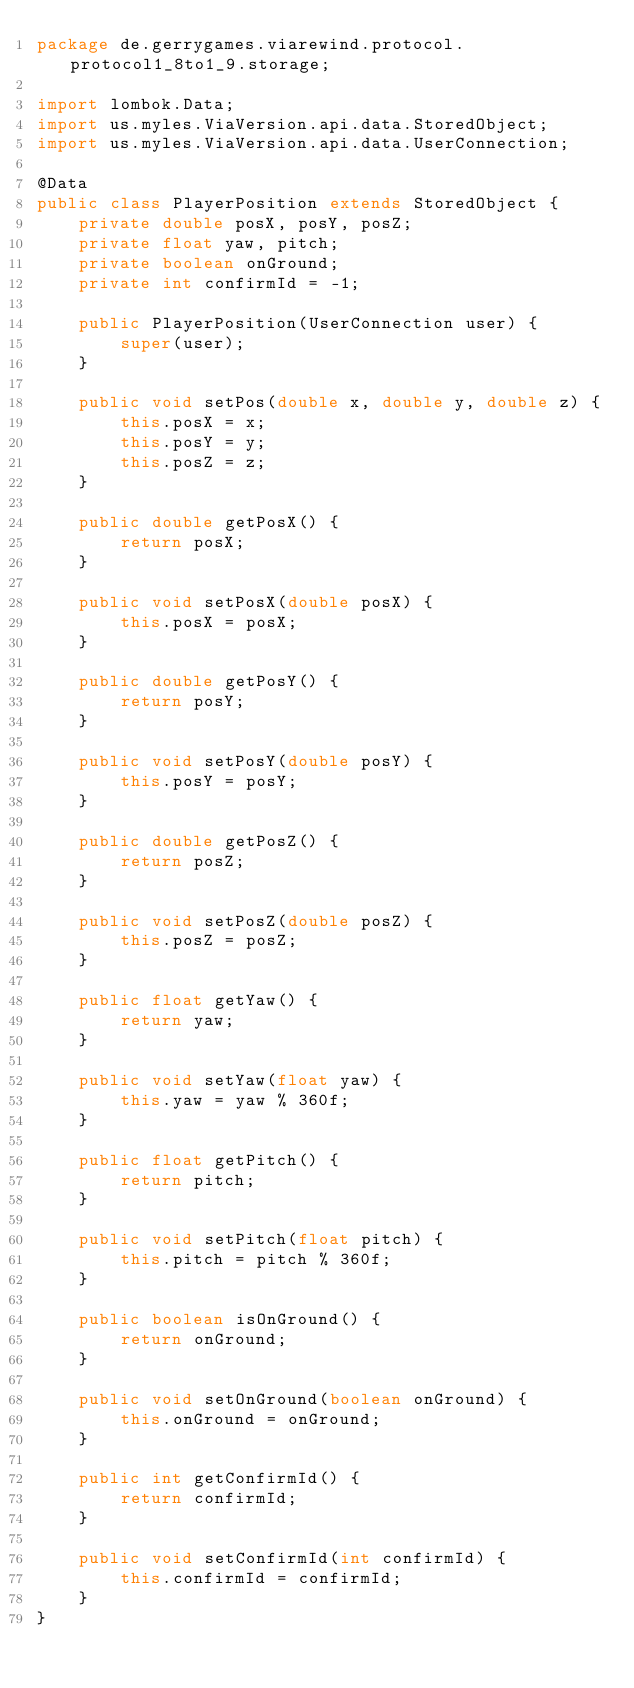<code> <loc_0><loc_0><loc_500><loc_500><_Java_>package de.gerrygames.viarewind.protocol.protocol1_8to1_9.storage;

import lombok.Data;
import us.myles.ViaVersion.api.data.StoredObject;
import us.myles.ViaVersion.api.data.UserConnection;

@Data
public class PlayerPosition extends StoredObject {
	private double posX, posY, posZ;
	private float yaw, pitch;
	private boolean onGround;
	private int confirmId = -1;

	public PlayerPosition(UserConnection user) {
		super(user);
	}

	public void setPos(double x, double y, double z) {
		this.posX = x;
		this.posY = y;
		this.posZ = z;
	}

	public double getPosX() {
		return posX;
	}

	public void setPosX(double posX) {
		this.posX = posX;
	}

	public double getPosY() {
		return posY;
	}

	public void setPosY(double posY) {
		this.posY = posY;
	}

	public double getPosZ() {
		return posZ;
	}

	public void setPosZ(double posZ) {
		this.posZ = posZ;
	}

	public float getYaw() {
		return yaw;
	}

	public void setYaw(float yaw) {
		this.yaw = yaw % 360f;
	}

	public float getPitch() {
		return pitch;
	}

	public void setPitch(float pitch) {
		this.pitch = pitch % 360f;
	}

	public boolean isOnGround() {
		return onGround;
	}

	public void setOnGround(boolean onGround) {
		this.onGround = onGround;
	}

	public int getConfirmId() {
		return confirmId;
	}

	public void setConfirmId(int confirmId) {
		this.confirmId = confirmId;
	}
}
</code> 